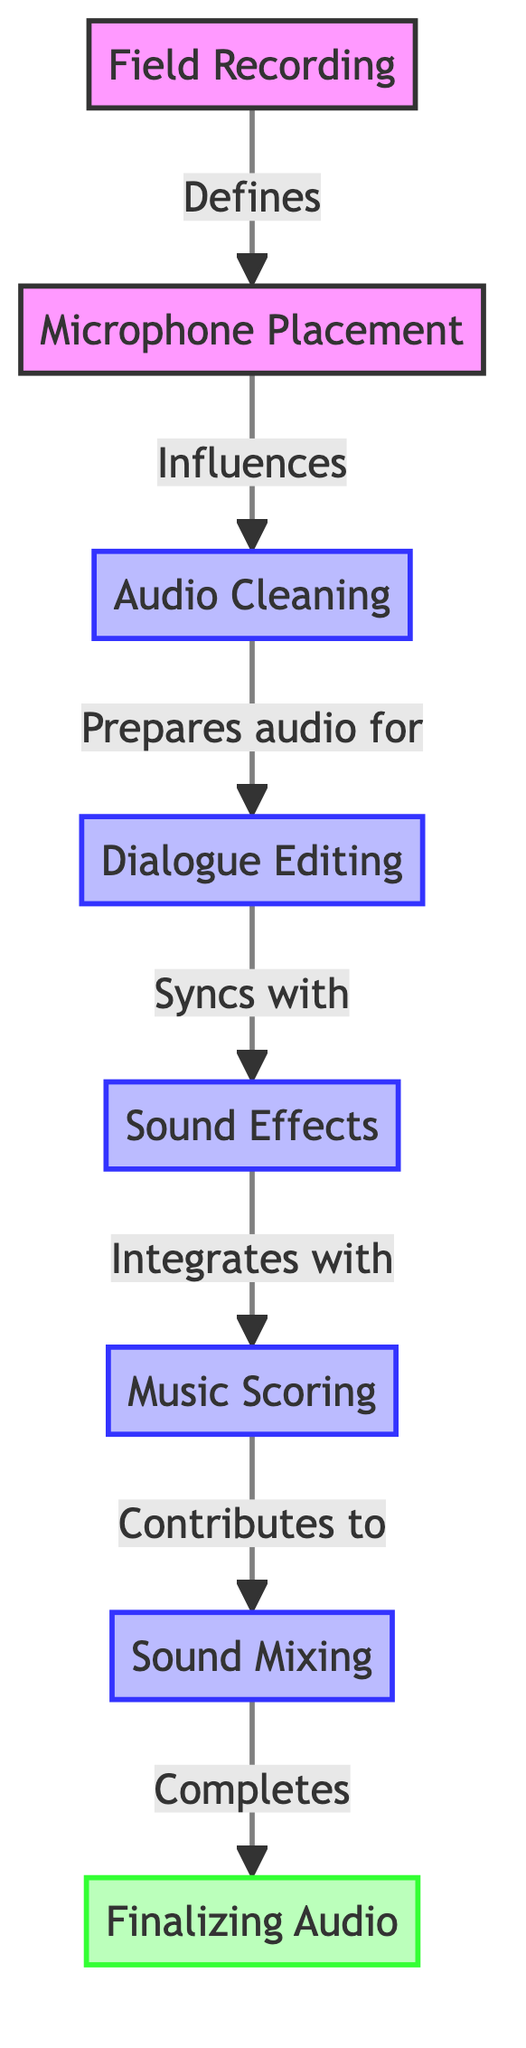What is the first step in the sound design workflow? The diagram shows "Field Recording" as the first step, indicated by the leftmost node in the flowchart.
Answer: Field Recording How many steps are there in the sound design workflow? Counting each node in the flowchart, there are a total of 7 steps in the workflow.
Answer: 7 What does "Microphone Placement" influence? The diagram specifies that "Microphone Placement" influences "Audio Cleaning", represented by the directed arrow connecting the two nodes.
Answer: Audio Cleaning Which step comes after "Dialogue Editing"? In the diagram, "Sound Effects" is the step that directly follows "Dialogue Editing", as indicated by the flow of arrows.
Answer: Sound Effects In which step is audio prepared for editing? The diagram shows that "Audio Cleaning" is the step where the audio is prepared for editing before moving on to dialogue editing.
Answer: Audio Cleaning What is the relationship between "Music Scoring" and "Sound Mixing"? According to the diagram, "Music Scoring" contributes to "Sound Mixing", which is depicted by the directional flow from the former to the latter.
Answer: Contributes to How are "Sound Effects" integrated in the workflow? The flowchart indicates that "Sound Effects" are integrated with "Music Scoring" in the order represented by the connections in the diagram.
Answer: Integrates with What is the last step in the sound design workflow? The final node in the diagram is "Finalizing Audio", making it the last step in the workflow.
Answer: Finalizing Audio 